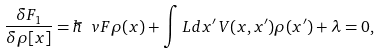<formula> <loc_0><loc_0><loc_500><loc_500>\frac { \delta F _ { 1 } } { \delta \rho [ x ] } = \hbar { \ } v F \rho ( x ) + \int L d x ^ { \prime } \, V ( x , x ^ { \prime } ) \rho ( x ^ { \prime } ) + \lambda = 0 ,</formula> 